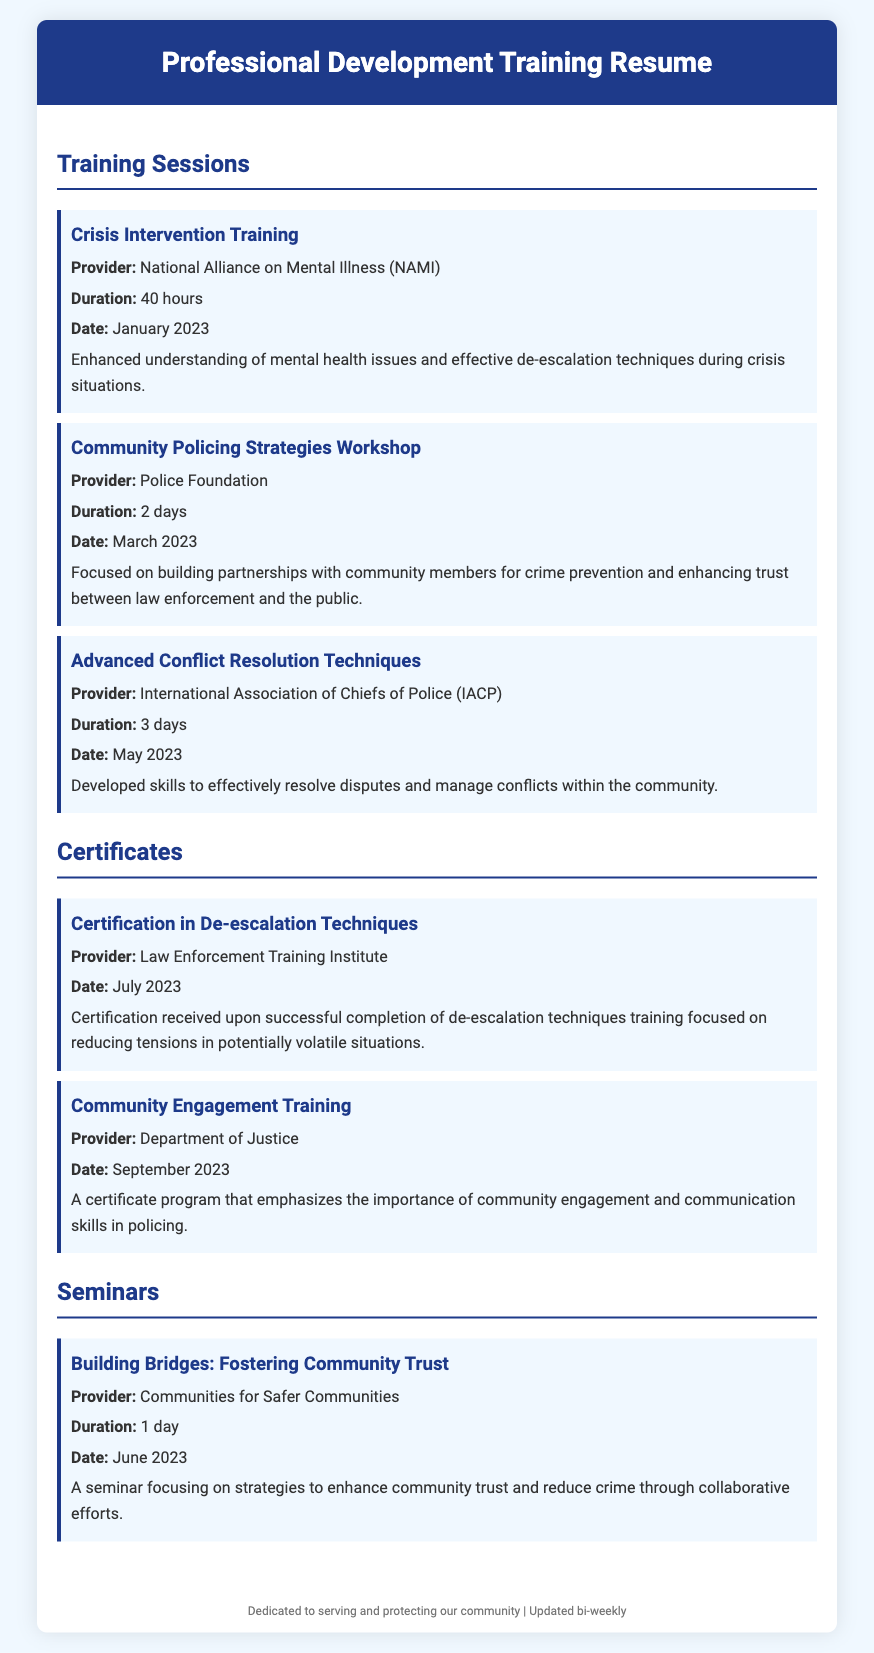what is the duration of the Crisis Intervention Training? The duration of the Crisis Intervention Training is stated in the document.
Answer: 40 hours who provided the Community Engagement Training? The document specifies the provider of the Community Engagement Training.
Answer: Department of Justice when did the Advanced Conflict Resolution Techniques training take place? The document lists the date of the Advanced Conflict Resolution Techniques training.
Answer: May 2023 how many days is the Community Policing Strategies Workshop? The document indicates the length of the Community Policing Strategies Workshop.
Answer: 2 days what is the main focus of the seminar titled "Building Bridges: Fostering Community Trust"? The document describes the seminar's focus area.
Answer: Community trust what certification was received in July 2023? The document mentions the certification received during that time.
Answer: Certification in De-escalation Techniques who organized the training sessions documented here? The document includes the organizations providing the training.
Answer: Various organizations what is the primary goal of the Community Policing Strategies Workshop? The goal of the workshop is summarized within the document.
Answer: Building partnerships how often is the document updated? The footer notes the update frequency of the resume.
Answer: Bi-weekly 